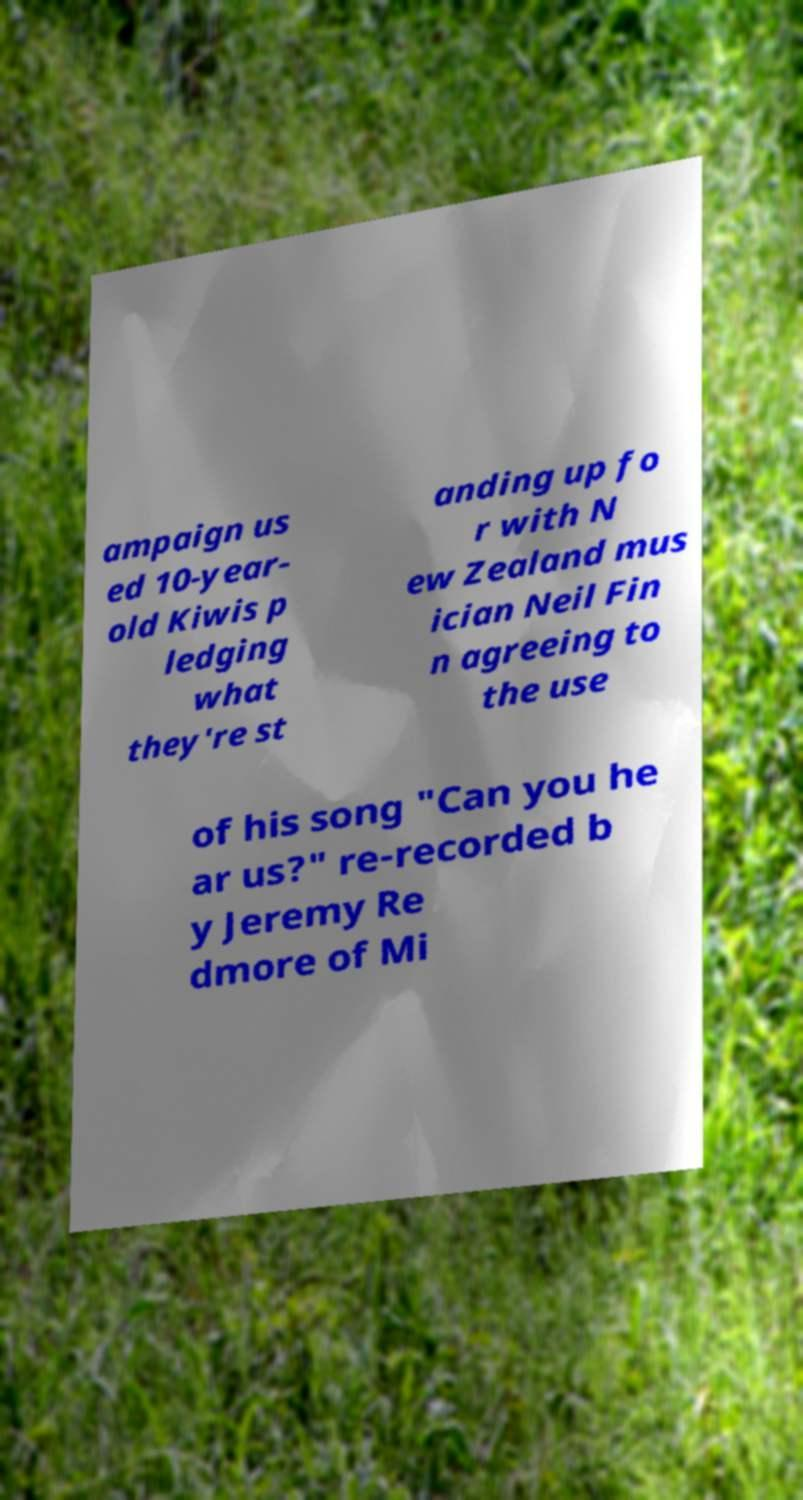For documentation purposes, I need the text within this image transcribed. Could you provide that? ampaign us ed 10-year- old Kiwis p ledging what they're st anding up fo r with N ew Zealand mus ician Neil Fin n agreeing to the use of his song "Can you he ar us?" re-recorded b y Jeremy Re dmore of Mi 